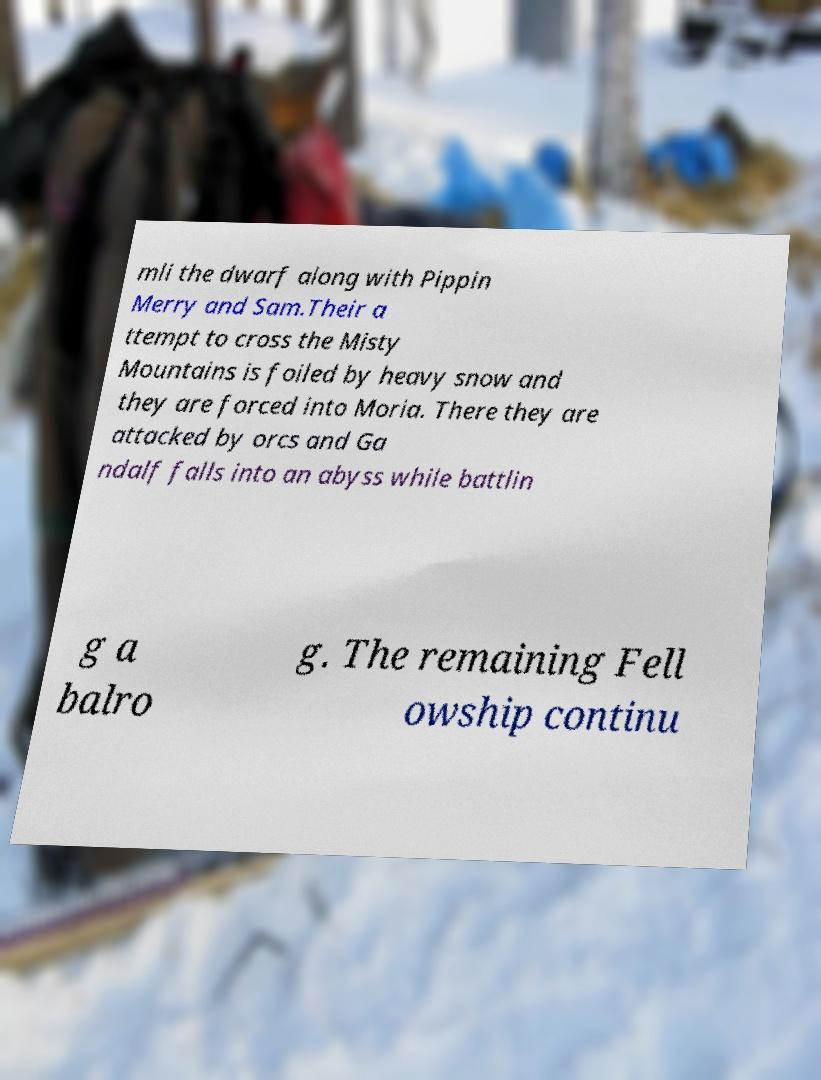Could you assist in decoding the text presented in this image and type it out clearly? mli the dwarf along with Pippin Merry and Sam.Their a ttempt to cross the Misty Mountains is foiled by heavy snow and they are forced into Moria. There they are attacked by orcs and Ga ndalf falls into an abyss while battlin g a balro g. The remaining Fell owship continu 